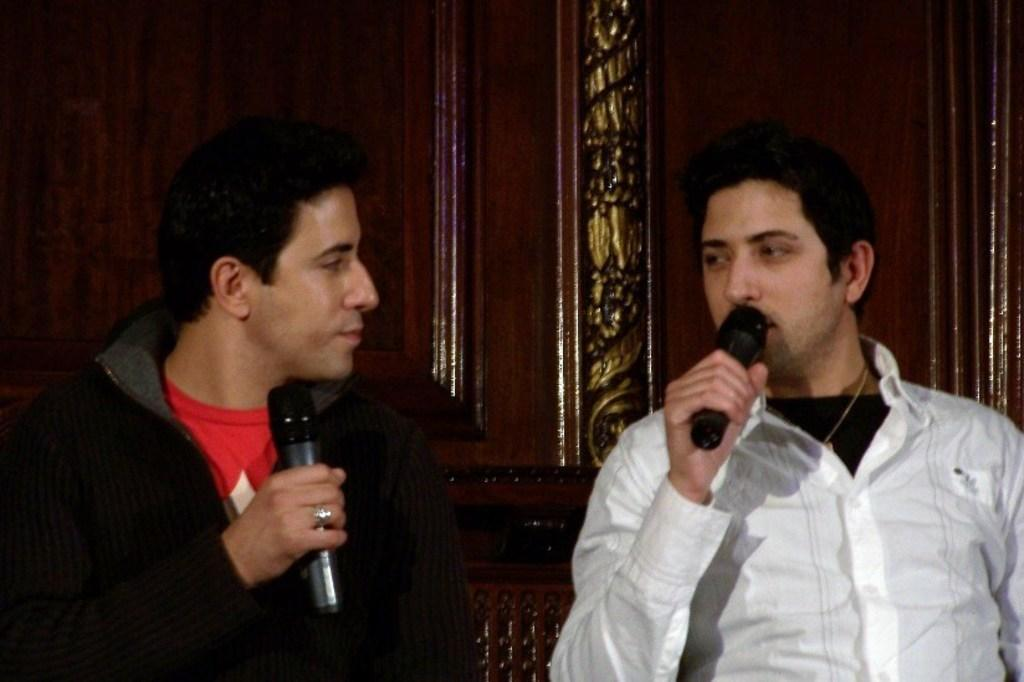How many people are in the image? There are two persons in the image. What are the persons holding in the image? Both persons are holding microphones. Can you describe the interaction between the two persons? The man on the left side is looking at the man on the right side. What can be seen in the background of the image? There are wooden cupboards in the background of the image. What type of rings are the persons wearing in the image? There are no rings visible on the persons in the image. Can you describe the shoes the persons are wearing in the image? There is no information about shoes in the image, as the focus is on the persons holding microphones. 